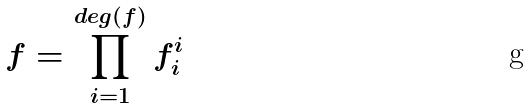Convert formula to latex. <formula><loc_0><loc_0><loc_500><loc_500>f = \prod _ { i = 1 } ^ { d e g ( f ) } f _ { i } ^ { i }</formula> 